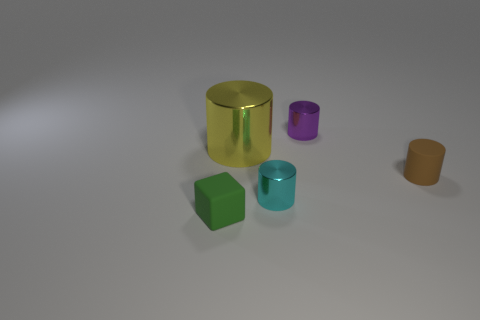Is the brown rubber cylinder the same size as the block?
Provide a succinct answer. Yes. How many metallic things are either tiny green blocks or small cyan balls?
Offer a terse response. 0. There is a block that is the same size as the brown thing; what is its material?
Keep it short and to the point. Rubber. What number of other things are the same material as the small block?
Offer a very short reply. 1. Are there fewer matte things behind the big object than green cubes?
Ensure brevity in your answer.  Yes. Do the green matte object and the big yellow thing have the same shape?
Your response must be concise. No. What size is the matte object behind the cyan metallic thing that is in front of the object that is behind the big metallic cylinder?
Provide a succinct answer. Small. What is the material of the brown object that is the same shape as the tiny purple object?
Give a very brief answer. Rubber. Are there any other things that have the same size as the brown cylinder?
Your response must be concise. Yes. What size is the rubber thing to the left of the tiny cylinder that is behind the brown thing?
Provide a short and direct response. Small. 